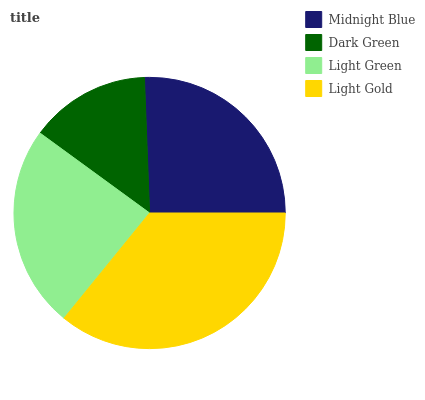Is Dark Green the minimum?
Answer yes or no. Yes. Is Light Gold the maximum?
Answer yes or no. Yes. Is Light Green the minimum?
Answer yes or no. No. Is Light Green the maximum?
Answer yes or no. No. Is Light Green greater than Dark Green?
Answer yes or no. Yes. Is Dark Green less than Light Green?
Answer yes or no. Yes. Is Dark Green greater than Light Green?
Answer yes or no. No. Is Light Green less than Dark Green?
Answer yes or no. No. Is Midnight Blue the high median?
Answer yes or no. Yes. Is Light Green the low median?
Answer yes or no. Yes. Is Light Gold the high median?
Answer yes or no. No. Is Dark Green the low median?
Answer yes or no. No. 